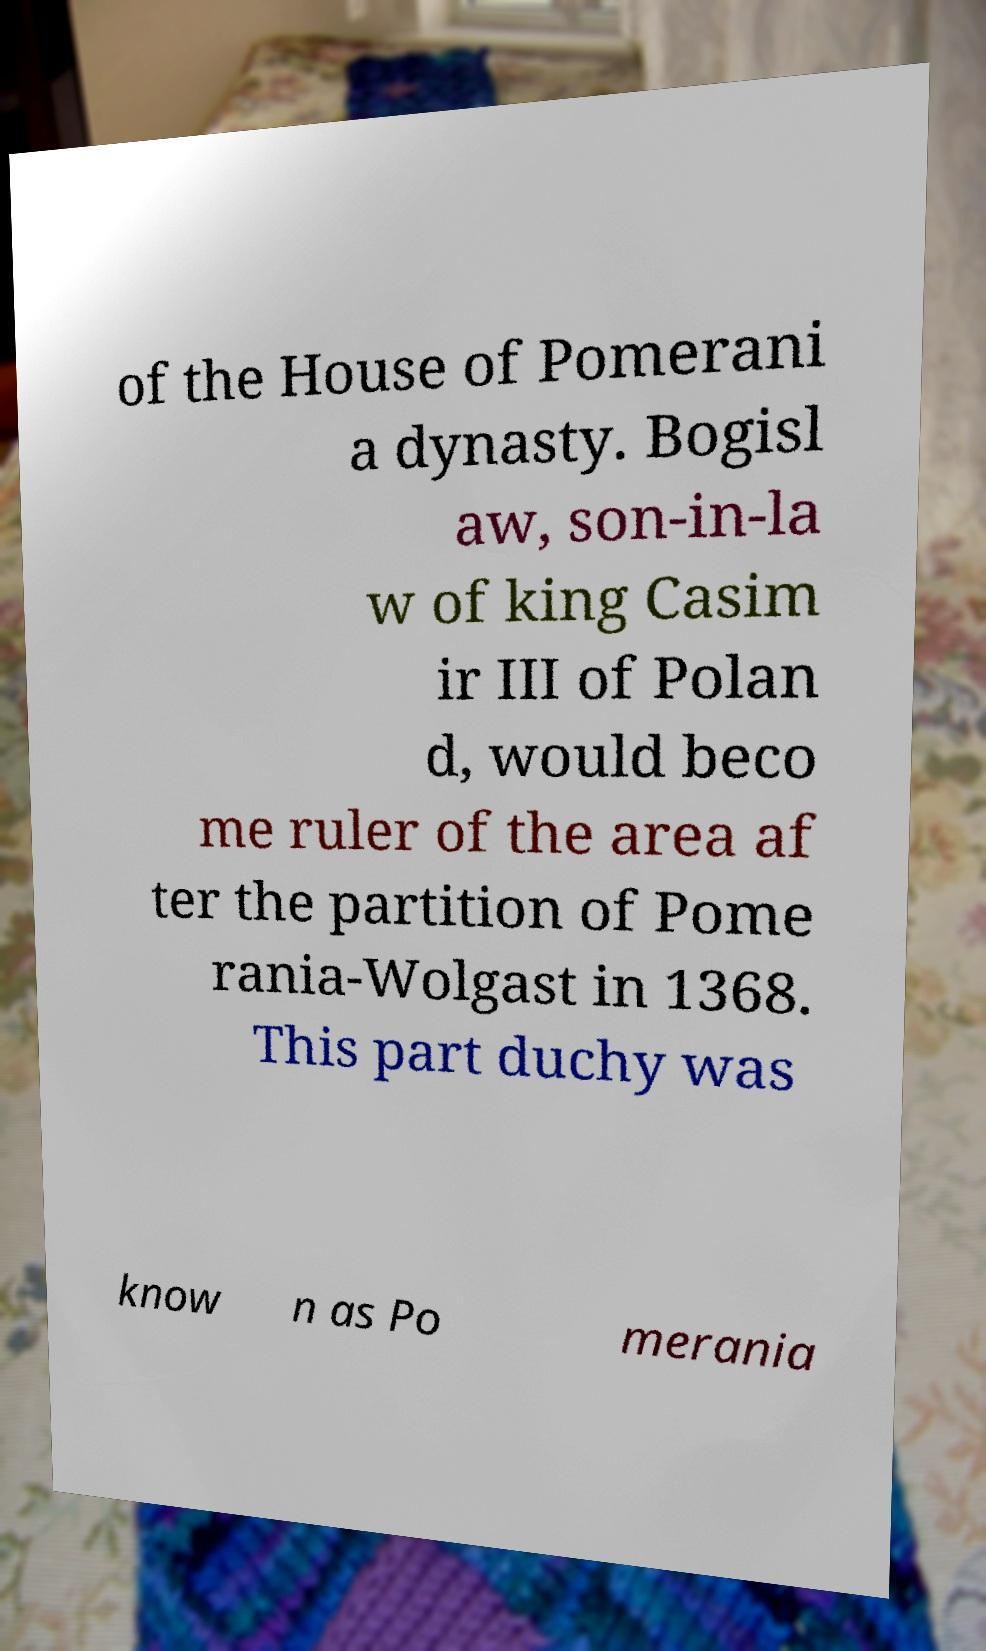Could you extract and type out the text from this image? of the House of Pomerani a dynasty. Bogisl aw, son-in-la w of king Casim ir III of Polan d, would beco me ruler of the area af ter the partition of Pome rania-Wolgast in 1368. This part duchy was know n as Po merania 